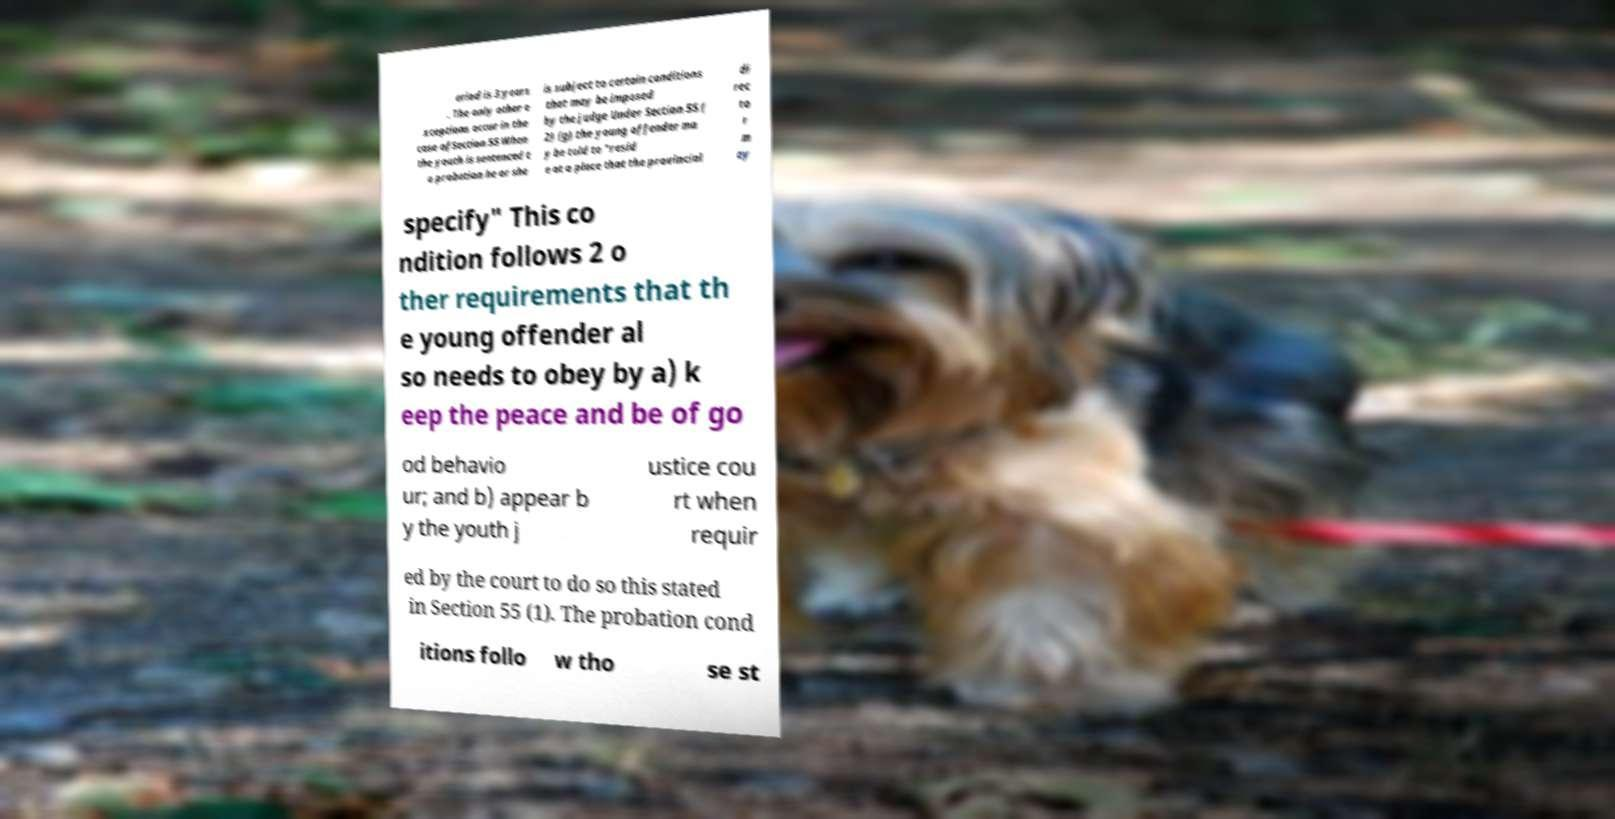Could you assist in decoding the text presented in this image and type it out clearly? eriod is 3 years . The only other e xceptions occur in the case ofSection 55 When the youth is sentenced t o probation he or she is subject to certain conditions that may be imposed by the judge Under Section 55 ( 2) (g) the young offender ma y be told to "resid e at a place that the provincial di rec to r m ay specify" This co ndition follows 2 o ther requirements that th e young offender al so needs to obey by a) k eep the peace and be of go od behavio ur; and b) appear b y the youth j ustice cou rt when requir ed by the court to do so this stated in Section 55 (1). The probation cond itions follo w tho se st 